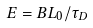<formula> <loc_0><loc_0><loc_500><loc_500>E = B L _ { 0 } / \tau _ { D }</formula> 